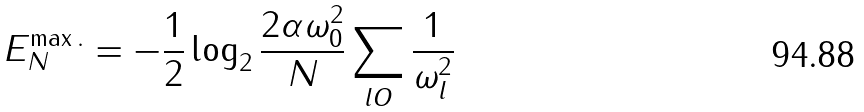<formula> <loc_0><loc_0><loc_500><loc_500>E _ { N } ^ { \max . } = - \frac { 1 } { 2 } \log _ { 2 } \frac { 2 \alpha \omega _ { 0 } ^ { 2 } } { N } \sum _ { l O } \frac { 1 } { \omega _ { l } ^ { 2 } }</formula> 